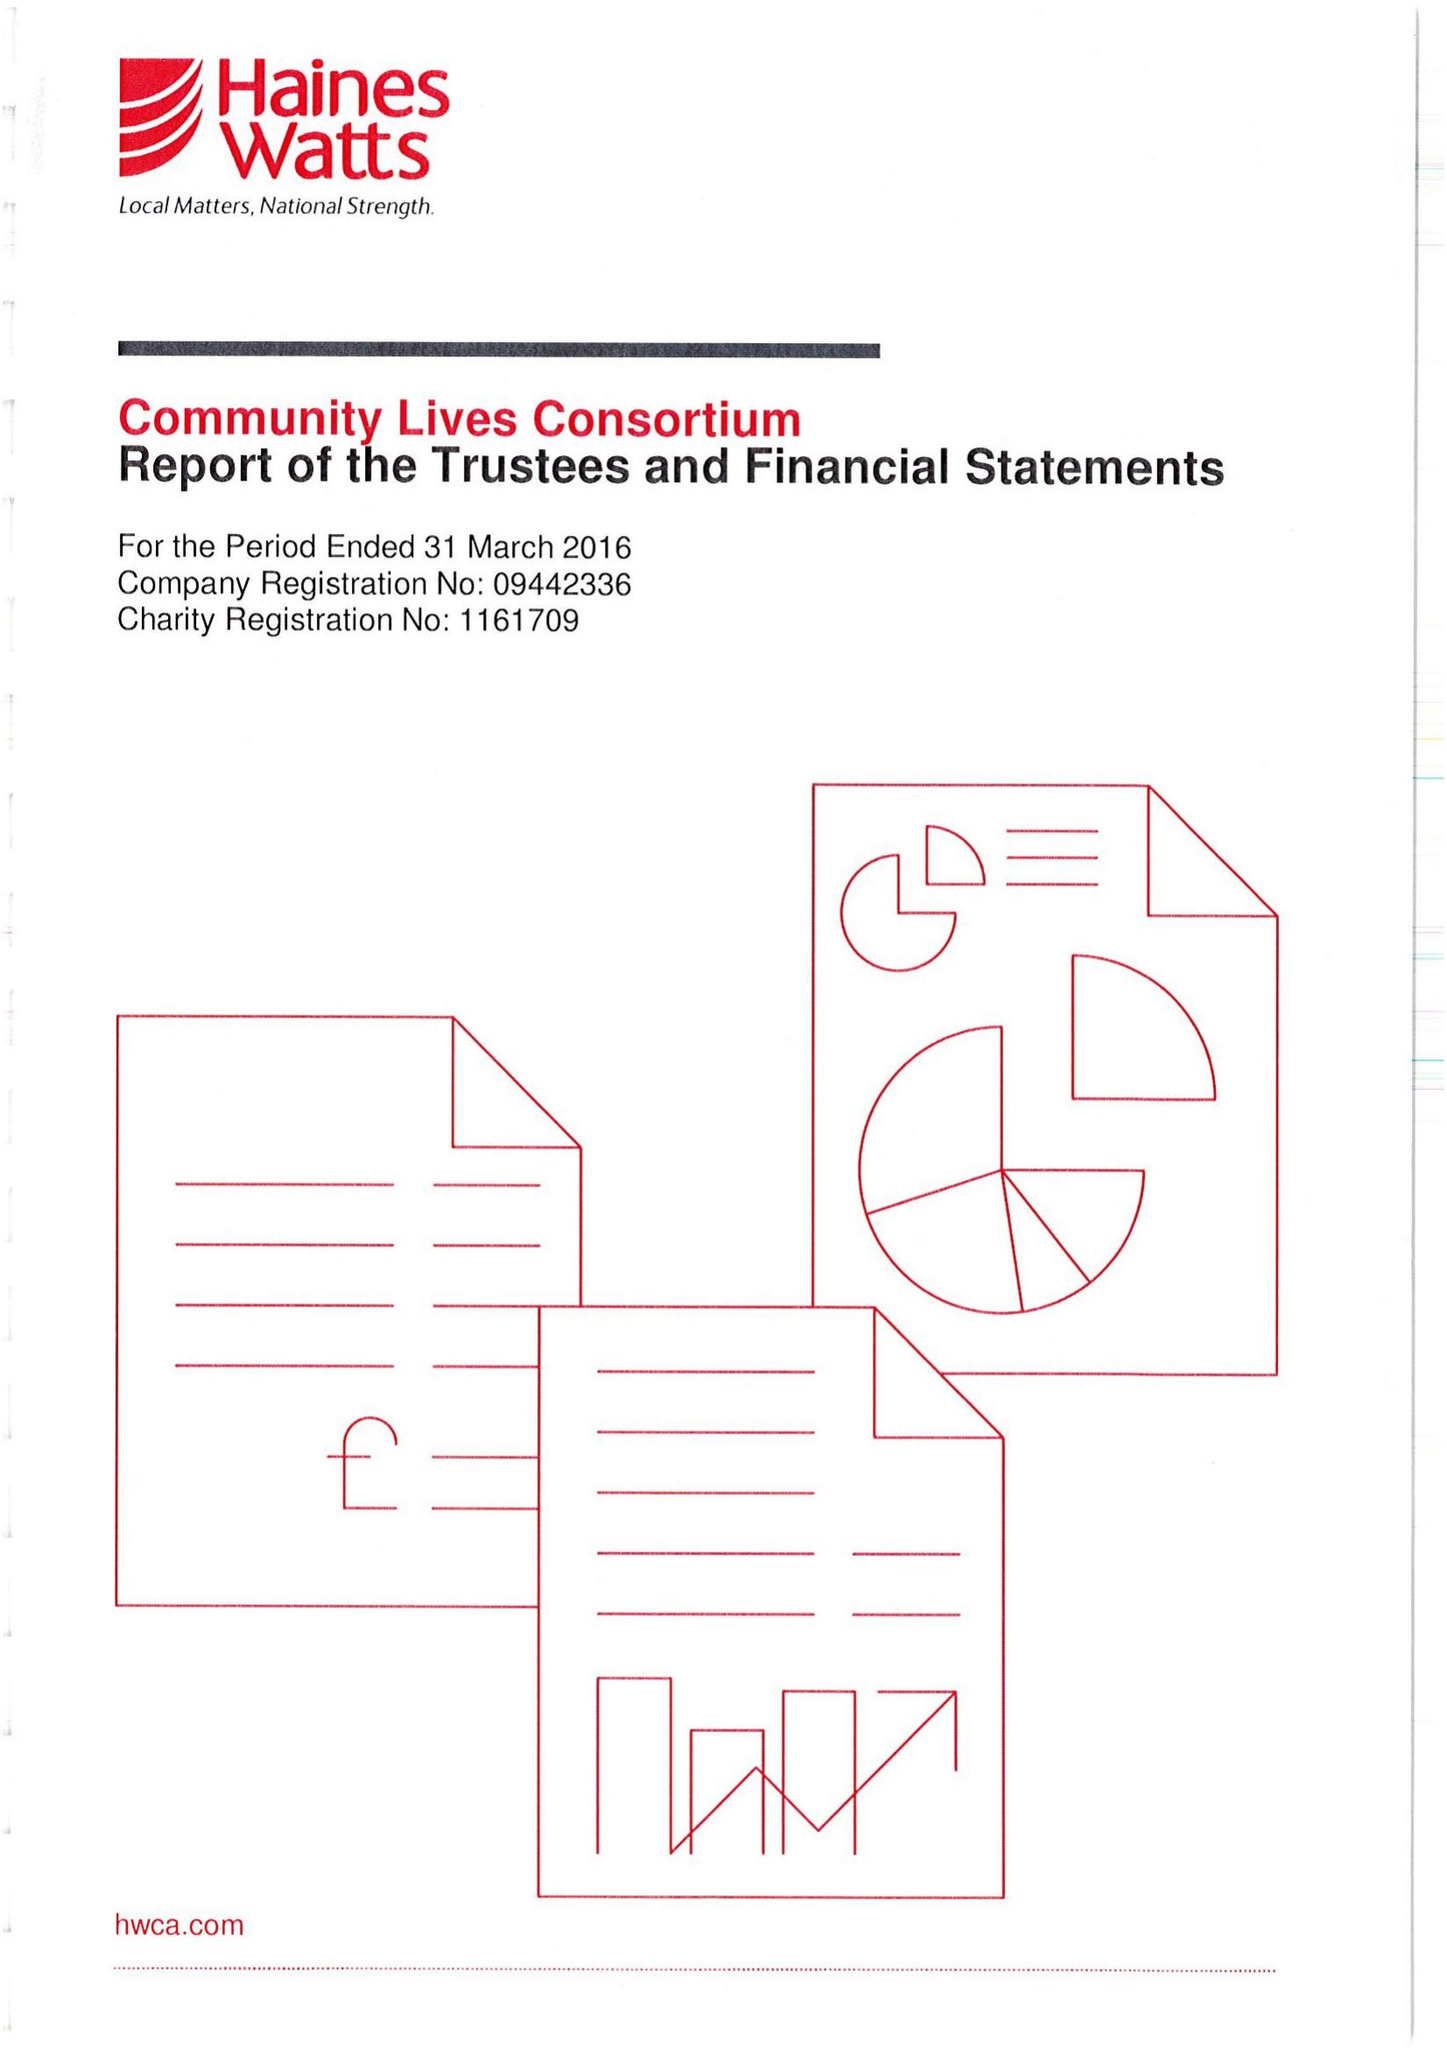What is the value for the address__street_line?
Answer the question using a single word or phrase. 24 WALTER ROAD 